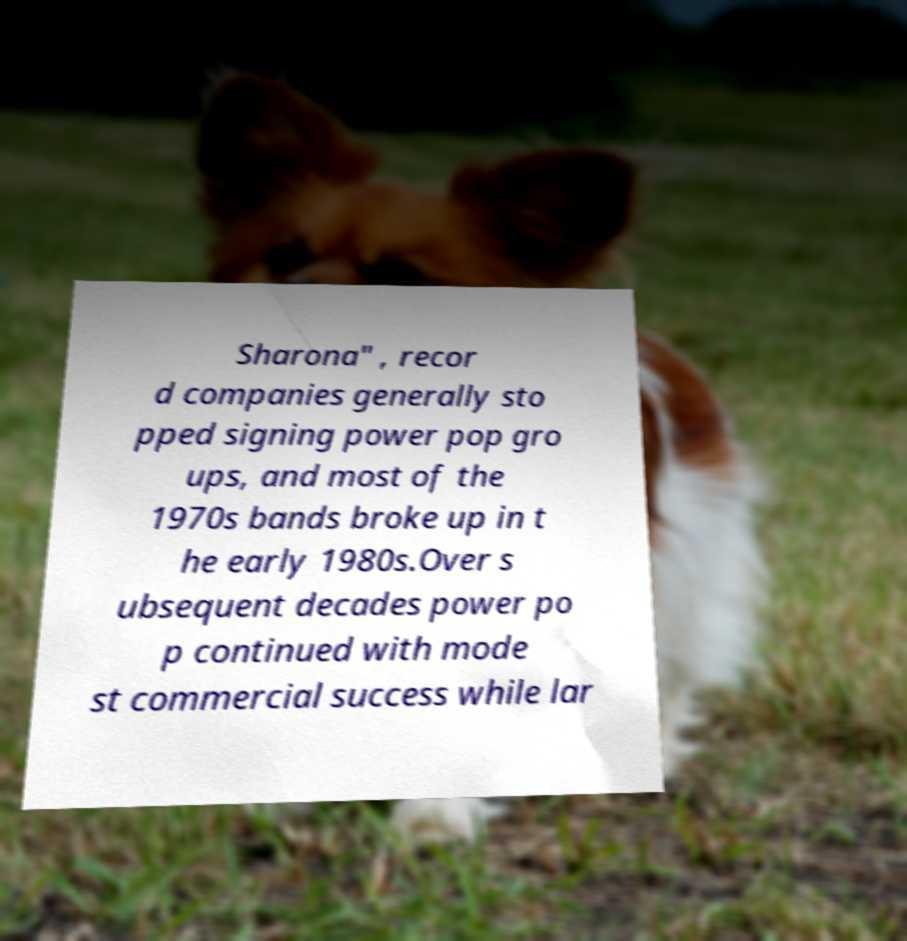Please read and relay the text visible in this image. What does it say? Sharona" , recor d companies generally sto pped signing power pop gro ups, and most of the 1970s bands broke up in t he early 1980s.Over s ubsequent decades power po p continued with mode st commercial success while lar 